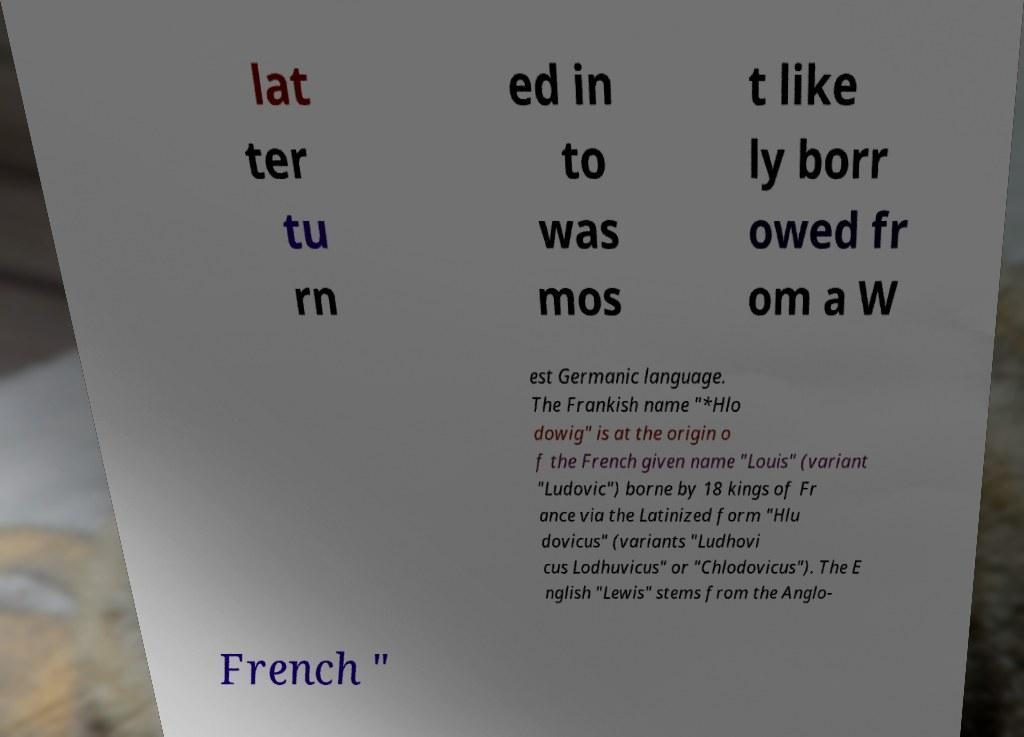Could you assist in decoding the text presented in this image and type it out clearly? lat ter tu rn ed in to was mos t like ly borr owed fr om a W est Germanic language. The Frankish name "*Hlo dowig" is at the origin o f the French given name "Louis" (variant "Ludovic") borne by 18 kings of Fr ance via the Latinized form "Hlu dovicus" (variants "Ludhovi cus Lodhuvicus" or "Chlodovicus"). The E nglish "Lewis" stems from the Anglo- French " 